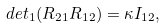Convert formula to latex. <formula><loc_0><loc_0><loc_500><loc_500>d e t _ { 1 } ( R _ { 2 1 } R _ { 1 2 } ) = \kappa I _ { 1 2 } ,</formula> 